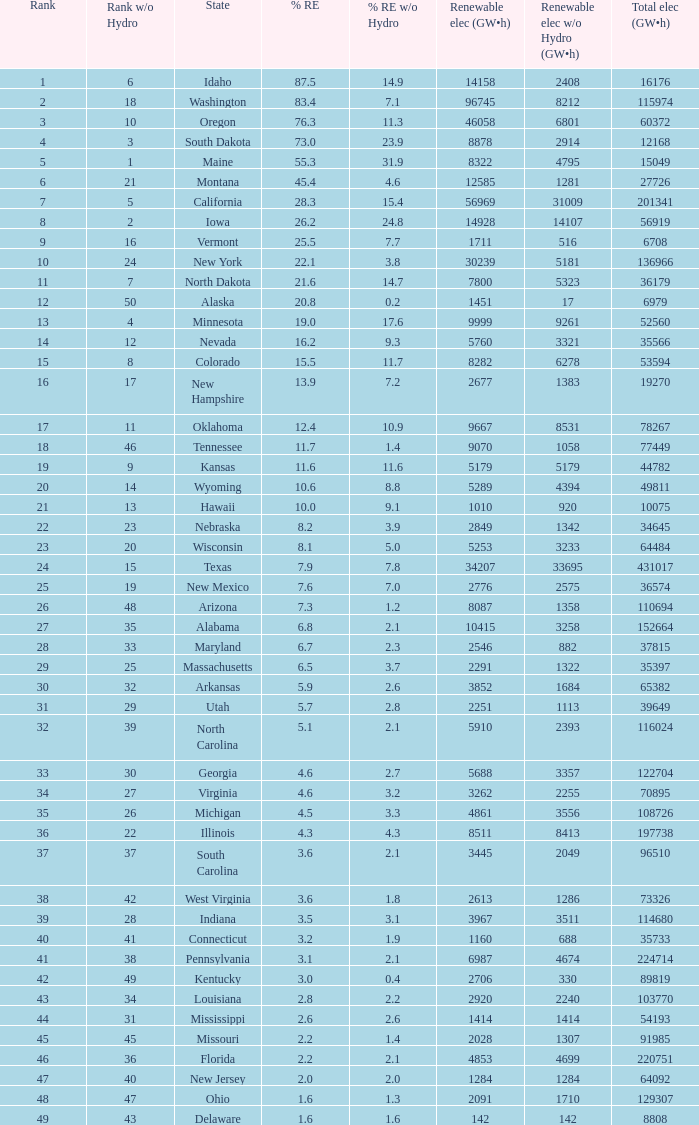Which states have renewable electricity equal to 9667 (gw×h)? Oklahoma. 